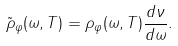Convert formula to latex. <formula><loc_0><loc_0><loc_500><loc_500>\tilde { \rho } _ { \varphi } ( \omega , T ) = \rho _ { \varphi } ( \omega , T ) \frac { d \nu } { d \omega } .</formula> 